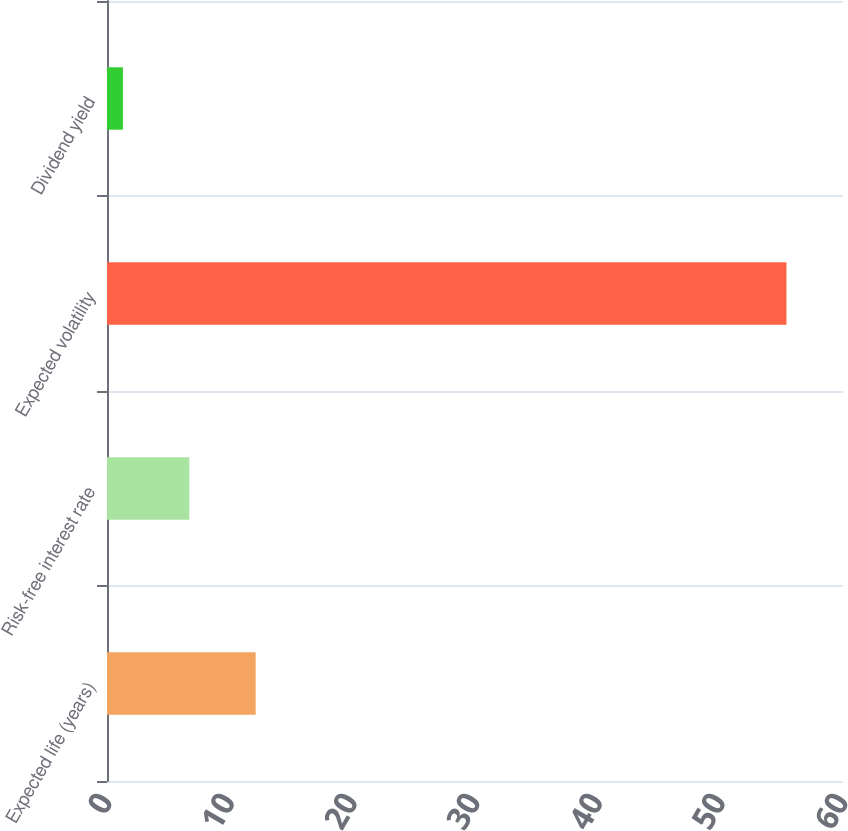<chart> <loc_0><loc_0><loc_500><loc_500><bar_chart><fcel>Expected life (years)<fcel>Risk-free interest rate<fcel>Expected volatility<fcel>Dividend yield<nl><fcel>12.12<fcel>6.71<fcel>55.39<fcel>1.3<nl></chart> 